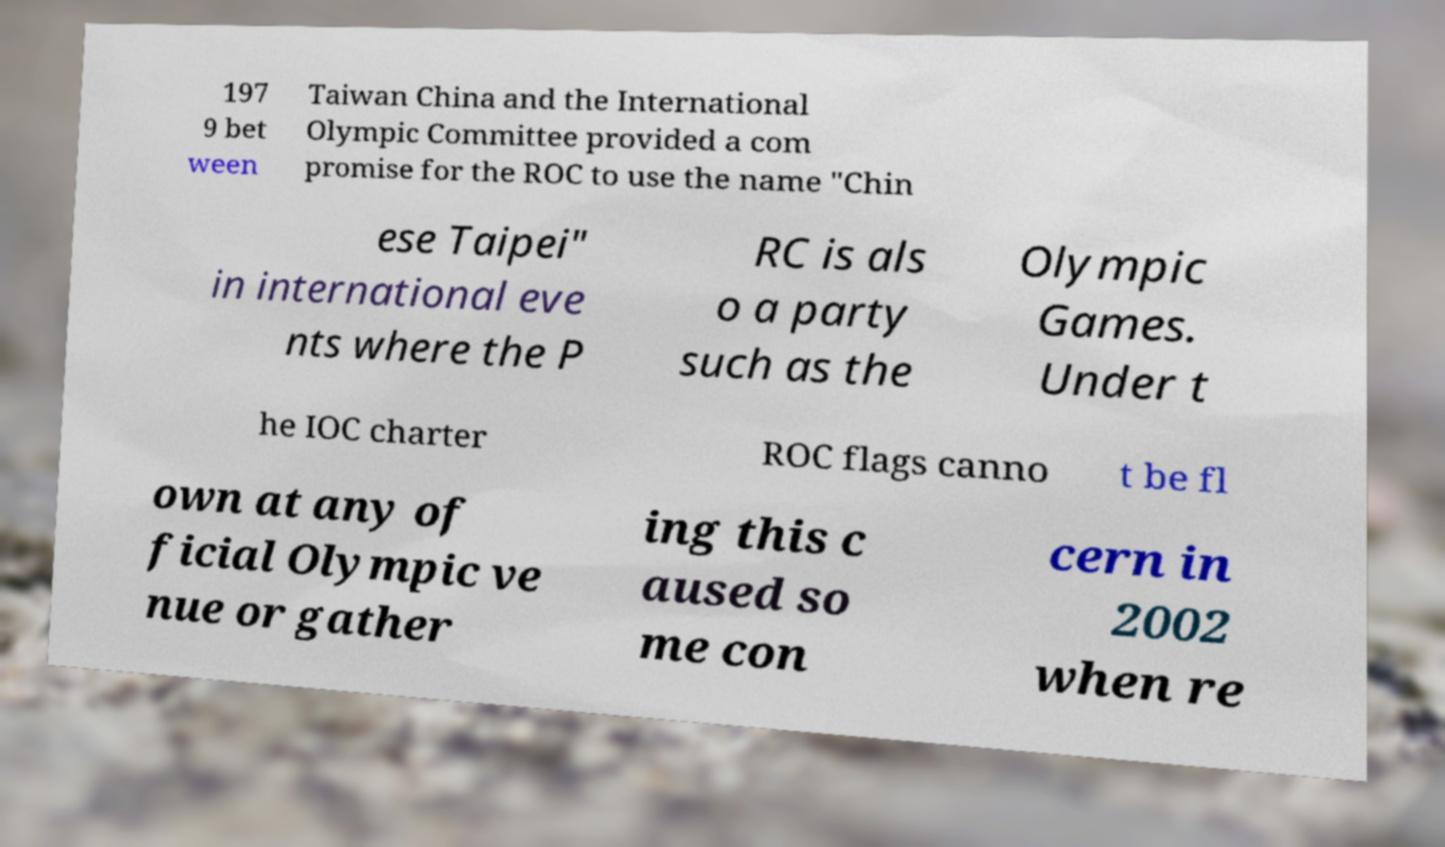There's text embedded in this image that I need extracted. Can you transcribe it verbatim? 197 9 bet ween Taiwan China and the International Olympic Committee provided a com promise for the ROC to use the name "Chin ese Taipei" in international eve nts where the P RC is als o a party such as the Olympic Games. Under t he IOC charter ROC flags canno t be fl own at any of ficial Olympic ve nue or gather ing this c aused so me con cern in 2002 when re 